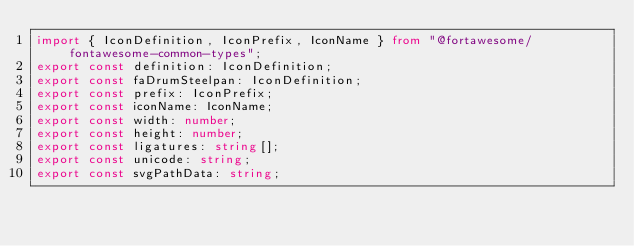Convert code to text. <code><loc_0><loc_0><loc_500><loc_500><_TypeScript_>import { IconDefinition, IconPrefix, IconName } from "@fortawesome/fontawesome-common-types";
export const definition: IconDefinition;
export const faDrumSteelpan: IconDefinition;
export const prefix: IconPrefix;
export const iconName: IconName; 
export const width: number;
export const height: number;
export const ligatures: string[];
export const unicode: string;
export const svgPathData: string;</code> 